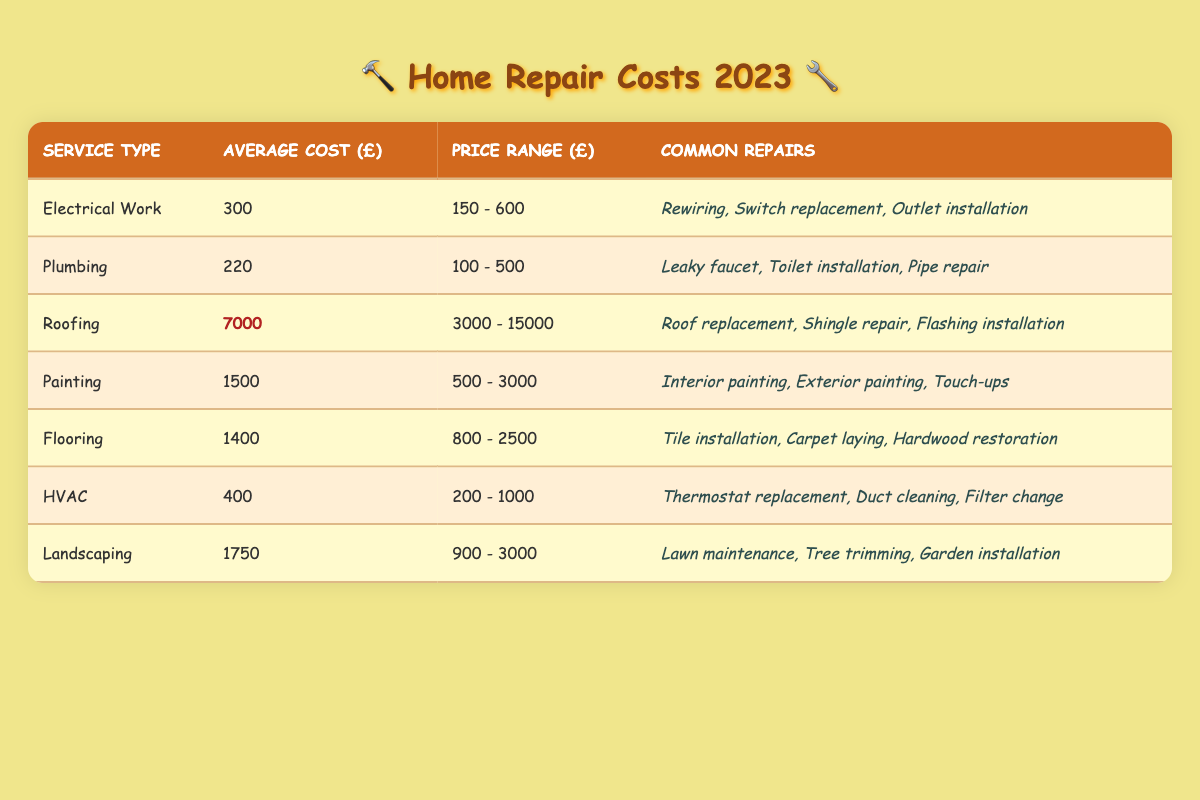What's the average cost of Electrical Work? The table indicates that the average cost for Electrical Work is listed as 300.
Answer: 300 What is the highest average cost service? By comparing the average costs listed in the table, Roofing has the highest cost at 7000.
Answer: 7000 How much does Plumbing service range from? The table shows Plumbing has a price range between 100 and 500.
Answer: 100 - 500 What are common repairs for HVAC? The table states that common repairs for HVAC include Thermostat replacement, Duct cleaning, and Filter change.
Answer: Thermostat replacement, Duct cleaning, Filter change If I want to do both Flooring and Painting, what would be the total average cost? The average cost of Flooring is 1400 and Painting is 1500. Adding these two together gives 1400 + 1500 = 2900.
Answer: 2900 Is the average cost of Landscaping higher than Plumbing? The average cost of Landscaping is 1750, while Plumbing is 220. Since 1750 is greater than 220, the answer is yes.
Answer: Yes What’s the price range of Roofing? Roofing has a price range from 3000 to 15000 as per the table.
Answer: 3000 - 15000 What is the average cost difference between Landscaping and Painting? The average cost for Landscaping is 1750 and for Painting is 1500. The difference is calculated as 1750 - 1500 = 250.
Answer: 250 Which service type has the lowest average cost? By examining the average costs in the table, Plumbing has the lowest average cost at 220.
Answer: Plumbing Can you identify whether the average cost of Flooring is above or below 1500? Flooring has an average cost of 1400, which is below 1500. Therefore, the answer is below.
Answer: Below How does the price range of HVAC compare to the price range of Electrical Work? HVAC has a price range of 200 to 1000, while Electrical Work ranges from 150 to 600. Since 200 is greater than 150 and 1000 is greater than 600, HVAC has a wider price range.
Answer: Wider 